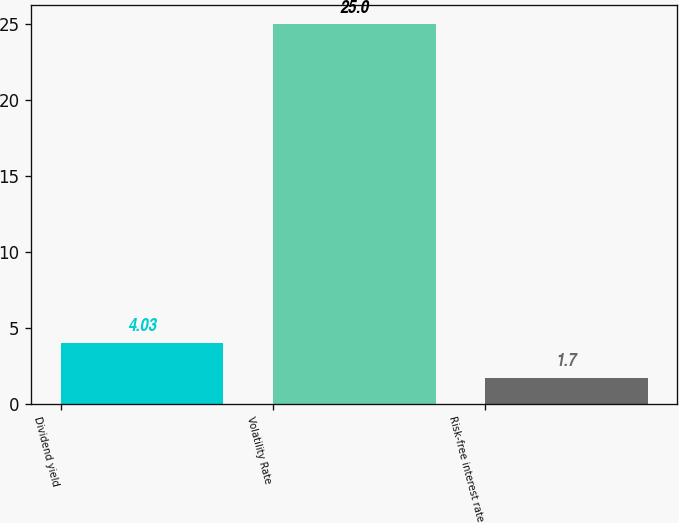<chart> <loc_0><loc_0><loc_500><loc_500><bar_chart><fcel>Dividend yield<fcel>Volatility Rate<fcel>Risk-free interest rate<nl><fcel>4.03<fcel>25<fcel>1.7<nl></chart> 